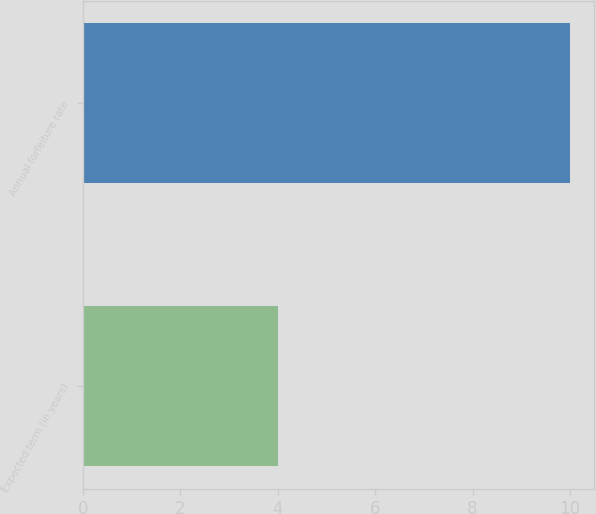<chart> <loc_0><loc_0><loc_500><loc_500><bar_chart><fcel>Expected term (in years)<fcel>Annual forfeiture rate<nl><fcel>4<fcel>10<nl></chart> 